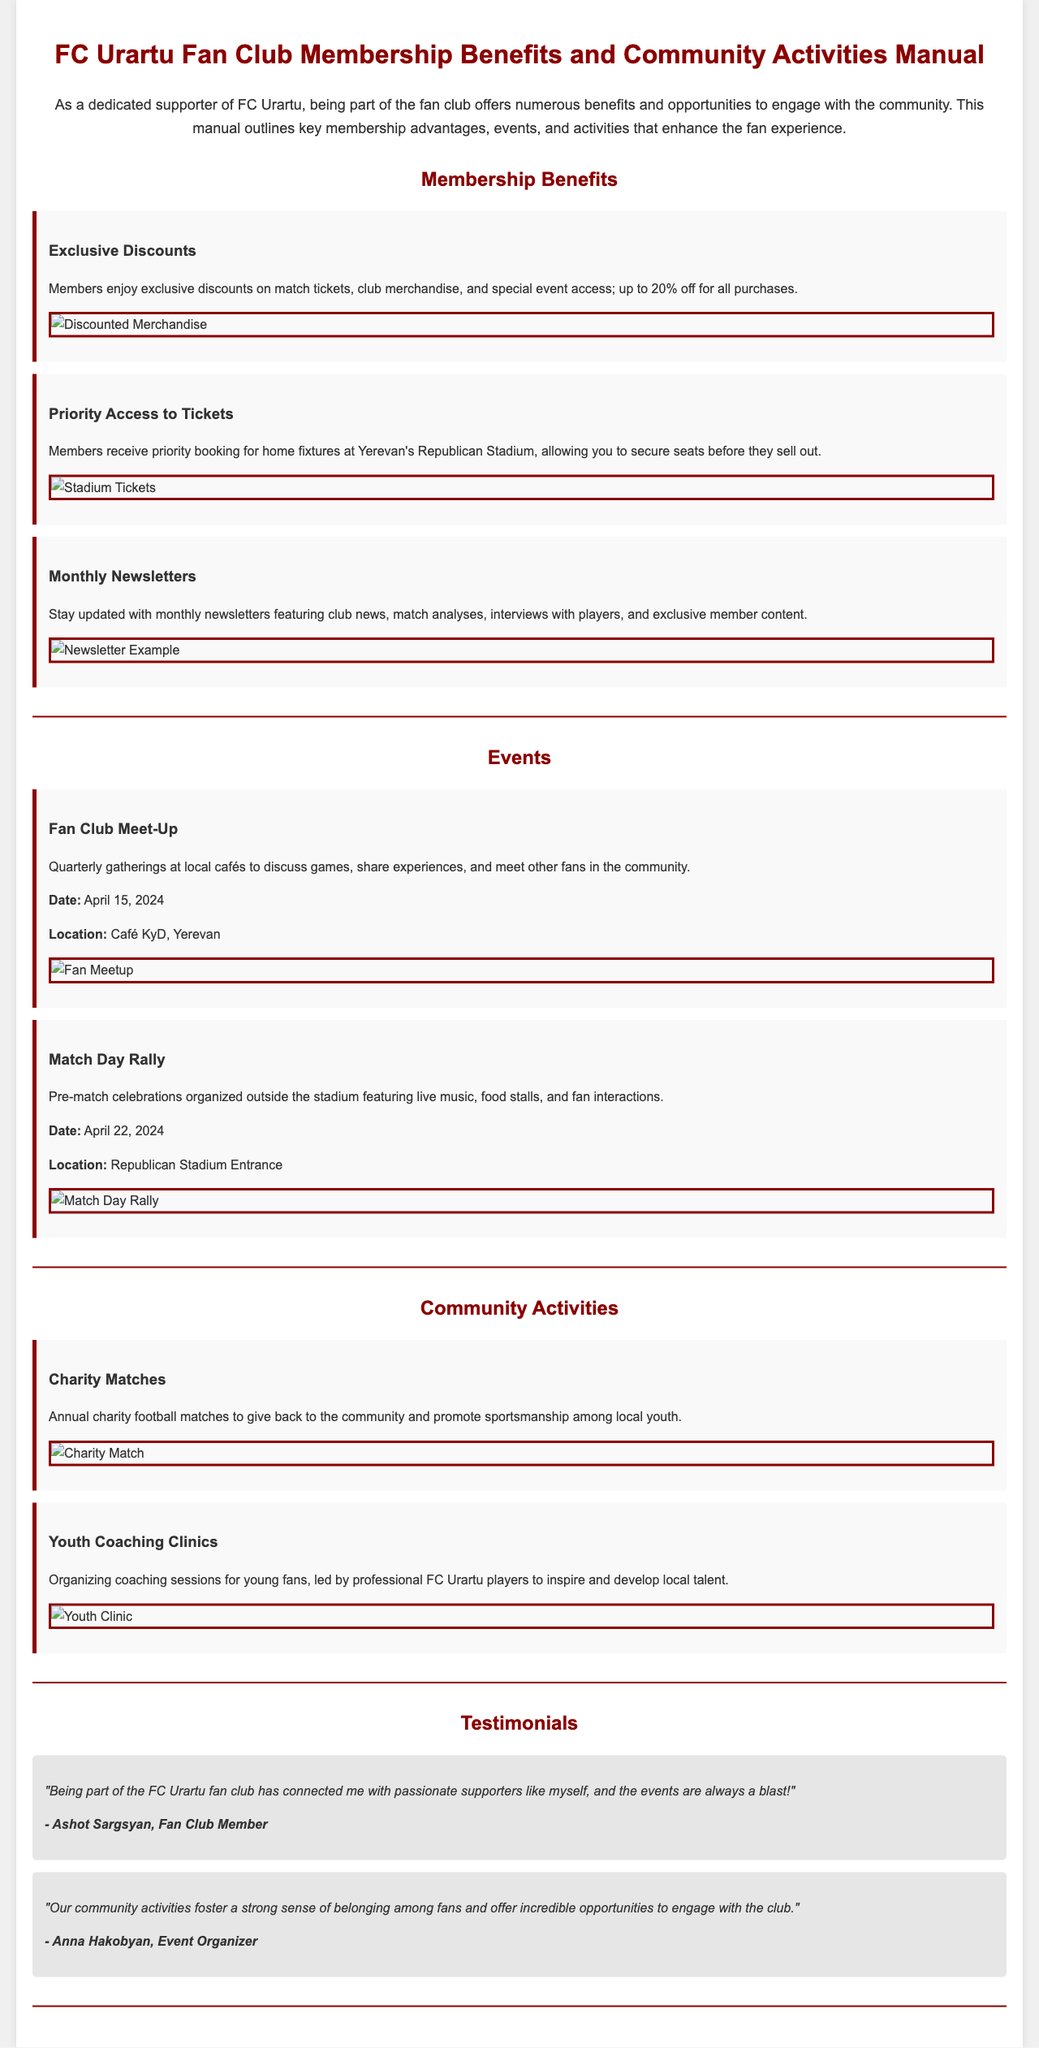What is the percentage of discounts for members? The document states that members enjoy exclusive discounts of up to 20% for all purchases.
Answer: 20% When is the Fan Club Meet-Up scheduled? The document mentions that the Fan Club Meet-Up is scheduled for April 15, 2024.
Answer: April 15, 2024 What is the main purpose of the Youth Coaching Clinics? The document indicates that the Youth Coaching Clinics aim to inspire and develop local talent among young fans.
Answer: Inspire and develop local talent Where are the quarterly meet-ups held? The document specifies that quarterly gatherings are held at local cafés, with one noted being Café KyD, Yerevan.
Answer: Café KyD, Yerevan What is included in the monthly newsletters? The document outlines that the monthly newsletters include club news, match analyses, interviews with players, and exclusive member content.
Answer: Club news, match analyses, interviews with players, exclusive content Who provided a testimonial about community activities? The document includes a testimonial from Anna Hakobyan, identified as an event organizer, regarding community activities.
Answer: Anna Hakobyan What event features live music and food stalls? According to the document, the Match Day Rally features live music, food stalls, and fan interactions before matches.
Answer: Match Day Rally What color is the title prominently displayed in the document? The document shows that the color used for the title is dark red (#8B0000).
Answer: Dark red 